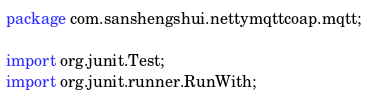<code> <loc_0><loc_0><loc_500><loc_500><_Java_>package com.sanshengshui.nettymqttcoap.mqtt;

import org.junit.Test;
import org.junit.runner.RunWith;</code> 